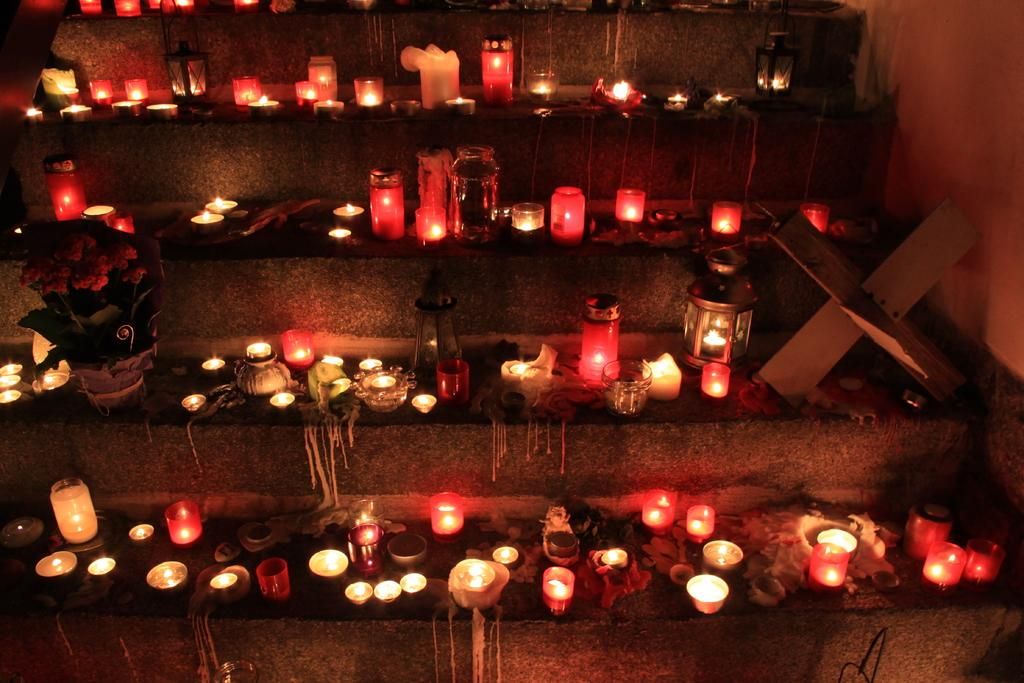What can be seen on the steps in the image? There are candles, lights, and plants on the steps in the image. How many different elements are present on the steps? There are three different elements present on the steps: candles, lights, and plants. What is visible in the top right corner of the image? There is a wall visible in the top right corner of the image. What type of clover can be seen growing on the steps in the image? There is no clover present on the steps in the image. What type of support is provided by the steps in the image? The steps in the image are not providing support for any object or person; they are simply a part of the scene. 